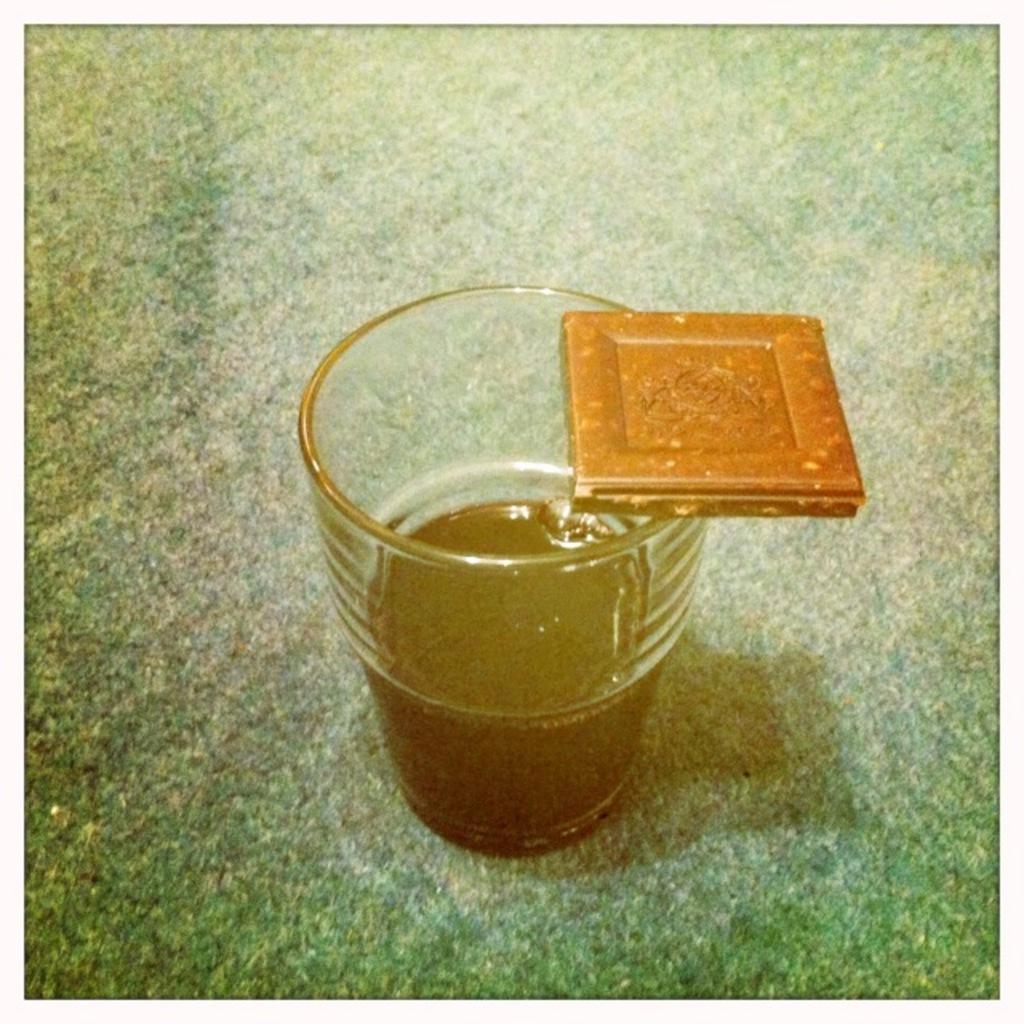Can you describe this image briefly? In the center of the image there is a glass. 